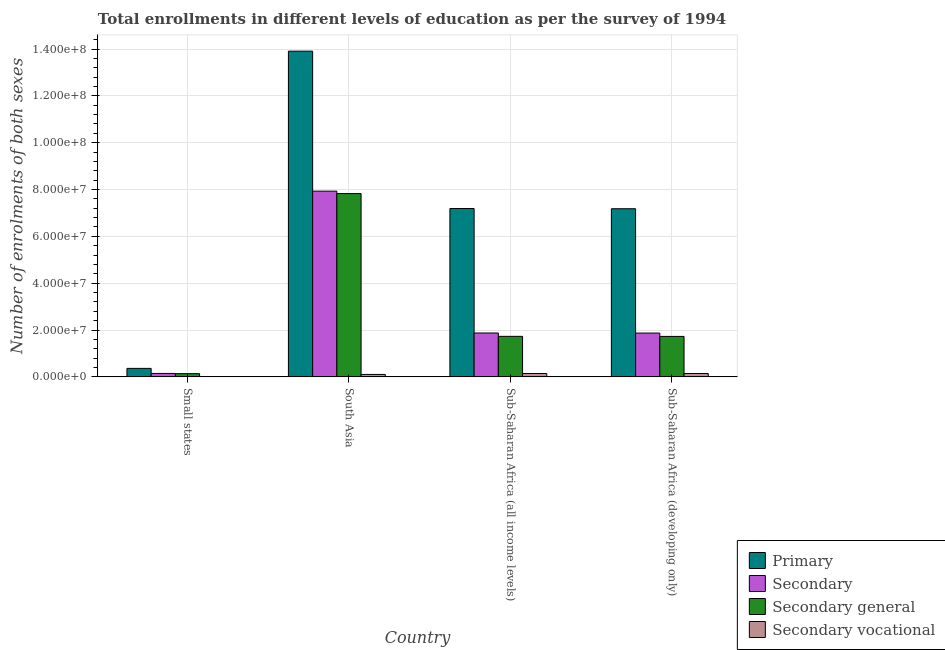How many bars are there on the 1st tick from the left?
Your response must be concise. 4. How many bars are there on the 2nd tick from the right?
Provide a short and direct response. 4. What is the label of the 1st group of bars from the left?
Keep it short and to the point. Small states. What is the number of enrolments in primary education in Sub-Saharan Africa (all income levels)?
Keep it short and to the point. 7.19e+07. Across all countries, what is the maximum number of enrolments in secondary education?
Your answer should be very brief. 7.93e+07. Across all countries, what is the minimum number of enrolments in secondary vocational education?
Your answer should be compact. 9.29e+04. In which country was the number of enrolments in primary education minimum?
Your answer should be compact. Small states. What is the total number of enrolments in secondary education in the graph?
Provide a short and direct response. 1.18e+08. What is the difference between the number of enrolments in secondary education in Sub-Saharan Africa (all income levels) and that in Sub-Saharan Africa (developing only)?
Make the answer very short. 2.59e+04. What is the difference between the number of enrolments in secondary general education in Small states and the number of enrolments in secondary vocational education in Sub-Saharan Africa (developing only)?
Give a very brief answer. -5.62e+04. What is the average number of enrolments in secondary education per country?
Keep it short and to the point. 2.96e+07. What is the difference between the number of enrolments in secondary education and number of enrolments in secondary vocational education in Small states?
Make the answer very short. 1.38e+06. What is the ratio of the number of enrolments in secondary education in Small states to that in South Asia?
Offer a very short reply. 0.02. Is the number of enrolments in primary education in Small states less than that in South Asia?
Your answer should be very brief. Yes. Is the difference between the number of enrolments in primary education in Small states and Sub-Saharan Africa (developing only) greater than the difference between the number of enrolments in secondary education in Small states and Sub-Saharan Africa (developing only)?
Give a very brief answer. No. What is the difference between the highest and the second highest number of enrolments in secondary general education?
Keep it short and to the point. 6.10e+07. What is the difference between the highest and the lowest number of enrolments in secondary education?
Ensure brevity in your answer.  7.78e+07. In how many countries, is the number of enrolments in primary education greater than the average number of enrolments in primary education taken over all countries?
Ensure brevity in your answer.  3. What does the 3rd bar from the left in Small states represents?
Your answer should be very brief. Secondary general. What does the 2nd bar from the right in South Asia represents?
Make the answer very short. Secondary general. How many bars are there?
Provide a short and direct response. 16. Are all the bars in the graph horizontal?
Provide a succinct answer. No. How many countries are there in the graph?
Your response must be concise. 4. What is the difference between two consecutive major ticks on the Y-axis?
Offer a terse response. 2.00e+07. Are the values on the major ticks of Y-axis written in scientific E-notation?
Keep it short and to the point. Yes. Where does the legend appear in the graph?
Your answer should be compact. Bottom right. What is the title of the graph?
Make the answer very short. Total enrollments in different levels of education as per the survey of 1994. Does "Manufacturing" appear as one of the legend labels in the graph?
Give a very brief answer. No. What is the label or title of the X-axis?
Offer a very short reply. Country. What is the label or title of the Y-axis?
Offer a terse response. Number of enrolments of both sexes. What is the Number of enrolments of both sexes in Primary in Small states?
Your response must be concise. 3.62e+06. What is the Number of enrolments of both sexes of Secondary in Small states?
Offer a terse response. 1.47e+06. What is the Number of enrolments of both sexes of Secondary general in Small states?
Provide a short and direct response. 1.38e+06. What is the Number of enrolments of both sexes in Secondary vocational in Small states?
Provide a succinct answer. 9.29e+04. What is the Number of enrolments of both sexes of Primary in South Asia?
Offer a very short reply. 1.39e+08. What is the Number of enrolments of both sexes in Secondary in South Asia?
Make the answer very short. 7.93e+07. What is the Number of enrolments of both sexes of Secondary general in South Asia?
Your answer should be very brief. 7.83e+07. What is the Number of enrolments of both sexes in Secondary vocational in South Asia?
Your response must be concise. 1.04e+06. What is the Number of enrolments of both sexes of Primary in Sub-Saharan Africa (all income levels)?
Offer a terse response. 7.19e+07. What is the Number of enrolments of both sexes in Secondary in Sub-Saharan Africa (all income levels)?
Offer a very short reply. 1.87e+07. What is the Number of enrolments of both sexes in Secondary general in Sub-Saharan Africa (all income levels)?
Make the answer very short. 1.73e+07. What is the Number of enrolments of both sexes of Secondary vocational in Sub-Saharan Africa (all income levels)?
Provide a short and direct response. 1.44e+06. What is the Number of enrolments of both sexes in Primary in Sub-Saharan Africa (developing only)?
Offer a terse response. 7.18e+07. What is the Number of enrolments of both sexes of Secondary in Sub-Saharan Africa (developing only)?
Offer a very short reply. 1.87e+07. What is the Number of enrolments of both sexes of Secondary general in Sub-Saharan Africa (developing only)?
Provide a short and direct response. 1.73e+07. What is the Number of enrolments of both sexes in Secondary vocational in Sub-Saharan Africa (developing only)?
Your answer should be compact. 1.44e+06. Across all countries, what is the maximum Number of enrolments of both sexes in Primary?
Offer a terse response. 1.39e+08. Across all countries, what is the maximum Number of enrolments of both sexes of Secondary?
Offer a very short reply. 7.93e+07. Across all countries, what is the maximum Number of enrolments of both sexes of Secondary general?
Your response must be concise. 7.83e+07. Across all countries, what is the maximum Number of enrolments of both sexes in Secondary vocational?
Offer a very short reply. 1.44e+06. Across all countries, what is the minimum Number of enrolments of both sexes in Primary?
Your answer should be compact. 3.62e+06. Across all countries, what is the minimum Number of enrolments of both sexes in Secondary?
Your response must be concise. 1.47e+06. Across all countries, what is the minimum Number of enrolments of both sexes in Secondary general?
Make the answer very short. 1.38e+06. Across all countries, what is the minimum Number of enrolments of both sexes of Secondary vocational?
Your answer should be compact. 9.29e+04. What is the total Number of enrolments of both sexes in Primary in the graph?
Make the answer very short. 2.86e+08. What is the total Number of enrolments of both sexes of Secondary in the graph?
Provide a short and direct response. 1.18e+08. What is the total Number of enrolments of both sexes of Secondary general in the graph?
Offer a very short reply. 1.14e+08. What is the total Number of enrolments of both sexes of Secondary vocational in the graph?
Your response must be concise. 4.01e+06. What is the difference between the Number of enrolments of both sexes of Primary in Small states and that in South Asia?
Your answer should be compact. -1.35e+08. What is the difference between the Number of enrolments of both sexes of Secondary in Small states and that in South Asia?
Make the answer very short. -7.78e+07. What is the difference between the Number of enrolments of both sexes in Secondary general in Small states and that in South Asia?
Your answer should be very brief. -7.69e+07. What is the difference between the Number of enrolments of both sexes in Secondary vocational in Small states and that in South Asia?
Offer a very short reply. -9.47e+05. What is the difference between the Number of enrolments of both sexes in Primary in Small states and that in Sub-Saharan Africa (all income levels)?
Ensure brevity in your answer.  -6.83e+07. What is the difference between the Number of enrolments of both sexes in Secondary in Small states and that in Sub-Saharan Africa (all income levels)?
Keep it short and to the point. -1.73e+07. What is the difference between the Number of enrolments of both sexes of Secondary general in Small states and that in Sub-Saharan Africa (all income levels)?
Make the answer very short. -1.59e+07. What is the difference between the Number of enrolments of both sexes in Secondary vocational in Small states and that in Sub-Saharan Africa (all income levels)?
Your answer should be very brief. -1.35e+06. What is the difference between the Number of enrolments of both sexes of Primary in Small states and that in Sub-Saharan Africa (developing only)?
Provide a succinct answer. -6.82e+07. What is the difference between the Number of enrolments of both sexes of Secondary in Small states and that in Sub-Saharan Africa (developing only)?
Provide a succinct answer. -1.72e+07. What is the difference between the Number of enrolments of both sexes of Secondary general in Small states and that in Sub-Saharan Africa (developing only)?
Provide a succinct answer. -1.59e+07. What is the difference between the Number of enrolments of both sexes in Secondary vocational in Small states and that in Sub-Saharan Africa (developing only)?
Your response must be concise. -1.34e+06. What is the difference between the Number of enrolments of both sexes in Primary in South Asia and that in Sub-Saharan Africa (all income levels)?
Offer a very short reply. 6.72e+07. What is the difference between the Number of enrolments of both sexes in Secondary in South Asia and that in Sub-Saharan Africa (all income levels)?
Keep it short and to the point. 6.06e+07. What is the difference between the Number of enrolments of both sexes in Secondary general in South Asia and that in Sub-Saharan Africa (all income levels)?
Provide a succinct answer. 6.10e+07. What is the difference between the Number of enrolments of both sexes in Secondary vocational in South Asia and that in Sub-Saharan Africa (all income levels)?
Your answer should be very brief. -3.99e+05. What is the difference between the Number of enrolments of both sexes in Primary in South Asia and that in Sub-Saharan Africa (developing only)?
Offer a terse response. 6.73e+07. What is the difference between the Number of enrolments of both sexes of Secondary in South Asia and that in Sub-Saharan Africa (developing only)?
Give a very brief answer. 6.06e+07. What is the difference between the Number of enrolments of both sexes in Secondary general in South Asia and that in Sub-Saharan Africa (developing only)?
Provide a short and direct response. 6.10e+07. What is the difference between the Number of enrolments of both sexes of Secondary vocational in South Asia and that in Sub-Saharan Africa (developing only)?
Your answer should be compact. -3.96e+05. What is the difference between the Number of enrolments of both sexes in Primary in Sub-Saharan Africa (all income levels) and that in Sub-Saharan Africa (developing only)?
Offer a very short reply. 8.57e+04. What is the difference between the Number of enrolments of both sexes in Secondary in Sub-Saharan Africa (all income levels) and that in Sub-Saharan Africa (developing only)?
Your answer should be very brief. 2.59e+04. What is the difference between the Number of enrolments of both sexes in Secondary general in Sub-Saharan Africa (all income levels) and that in Sub-Saharan Africa (developing only)?
Your response must be concise. 2.24e+04. What is the difference between the Number of enrolments of both sexes in Secondary vocational in Sub-Saharan Africa (all income levels) and that in Sub-Saharan Africa (developing only)?
Provide a short and direct response. 3508. What is the difference between the Number of enrolments of both sexes in Primary in Small states and the Number of enrolments of both sexes in Secondary in South Asia?
Ensure brevity in your answer.  -7.57e+07. What is the difference between the Number of enrolments of both sexes in Primary in Small states and the Number of enrolments of both sexes in Secondary general in South Asia?
Provide a short and direct response. -7.46e+07. What is the difference between the Number of enrolments of both sexes of Primary in Small states and the Number of enrolments of both sexes of Secondary vocational in South Asia?
Your answer should be compact. 2.58e+06. What is the difference between the Number of enrolments of both sexes of Secondary in Small states and the Number of enrolments of both sexes of Secondary general in South Asia?
Provide a succinct answer. -7.68e+07. What is the difference between the Number of enrolments of both sexes in Secondary in Small states and the Number of enrolments of both sexes in Secondary vocational in South Asia?
Give a very brief answer. 4.33e+05. What is the difference between the Number of enrolments of both sexes in Secondary general in Small states and the Number of enrolments of both sexes in Secondary vocational in South Asia?
Ensure brevity in your answer.  3.40e+05. What is the difference between the Number of enrolments of both sexes of Primary in Small states and the Number of enrolments of both sexes of Secondary in Sub-Saharan Africa (all income levels)?
Your answer should be very brief. -1.51e+07. What is the difference between the Number of enrolments of both sexes in Primary in Small states and the Number of enrolments of both sexes in Secondary general in Sub-Saharan Africa (all income levels)?
Keep it short and to the point. -1.37e+07. What is the difference between the Number of enrolments of both sexes in Primary in Small states and the Number of enrolments of both sexes in Secondary vocational in Sub-Saharan Africa (all income levels)?
Your answer should be very brief. 2.18e+06. What is the difference between the Number of enrolments of both sexes in Secondary in Small states and the Number of enrolments of both sexes in Secondary general in Sub-Saharan Africa (all income levels)?
Offer a very short reply. -1.58e+07. What is the difference between the Number of enrolments of both sexes in Secondary in Small states and the Number of enrolments of both sexes in Secondary vocational in Sub-Saharan Africa (all income levels)?
Your response must be concise. 3.33e+04. What is the difference between the Number of enrolments of both sexes in Secondary general in Small states and the Number of enrolments of both sexes in Secondary vocational in Sub-Saharan Africa (all income levels)?
Your response must be concise. -5.97e+04. What is the difference between the Number of enrolments of both sexes of Primary in Small states and the Number of enrolments of both sexes of Secondary in Sub-Saharan Africa (developing only)?
Ensure brevity in your answer.  -1.51e+07. What is the difference between the Number of enrolments of both sexes of Primary in Small states and the Number of enrolments of both sexes of Secondary general in Sub-Saharan Africa (developing only)?
Offer a very short reply. -1.37e+07. What is the difference between the Number of enrolments of both sexes of Primary in Small states and the Number of enrolments of both sexes of Secondary vocational in Sub-Saharan Africa (developing only)?
Provide a short and direct response. 2.19e+06. What is the difference between the Number of enrolments of both sexes in Secondary in Small states and the Number of enrolments of both sexes in Secondary general in Sub-Saharan Africa (developing only)?
Provide a succinct answer. -1.58e+07. What is the difference between the Number of enrolments of both sexes of Secondary in Small states and the Number of enrolments of both sexes of Secondary vocational in Sub-Saharan Africa (developing only)?
Offer a terse response. 3.68e+04. What is the difference between the Number of enrolments of both sexes in Secondary general in Small states and the Number of enrolments of both sexes in Secondary vocational in Sub-Saharan Africa (developing only)?
Keep it short and to the point. -5.62e+04. What is the difference between the Number of enrolments of both sexes of Primary in South Asia and the Number of enrolments of both sexes of Secondary in Sub-Saharan Africa (all income levels)?
Offer a very short reply. 1.20e+08. What is the difference between the Number of enrolments of both sexes of Primary in South Asia and the Number of enrolments of both sexes of Secondary general in Sub-Saharan Africa (all income levels)?
Provide a short and direct response. 1.22e+08. What is the difference between the Number of enrolments of both sexes of Primary in South Asia and the Number of enrolments of both sexes of Secondary vocational in Sub-Saharan Africa (all income levels)?
Keep it short and to the point. 1.38e+08. What is the difference between the Number of enrolments of both sexes of Secondary in South Asia and the Number of enrolments of both sexes of Secondary general in Sub-Saharan Africa (all income levels)?
Your answer should be very brief. 6.20e+07. What is the difference between the Number of enrolments of both sexes in Secondary in South Asia and the Number of enrolments of both sexes in Secondary vocational in Sub-Saharan Africa (all income levels)?
Provide a succinct answer. 7.79e+07. What is the difference between the Number of enrolments of both sexes of Secondary general in South Asia and the Number of enrolments of both sexes of Secondary vocational in Sub-Saharan Africa (all income levels)?
Keep it short and to the point. 7.68e+07. What is the difference between the Number of enrolments of both sexes of Primary in South Asia and the Number of enrolments of both sexes of Secondary in Sub-Saharan Africa (developing only)?
Your answer should be compact. 1.20e+08. What is the difference between the Number of enrolments of both sexes in Primary in South Asia and the Number of enrolments of both sexes in Secondary general in Sub-Saharan Africa (developing only)?
Offer a very short reply. 1.22e+08. What is the difference between the Number of enrolments of both sexes of Primary in South Asia and the Number of enrolments of both sexes of Secondary vocational in Sub-Saharan Africa (developing only)?
Ensure brevity in your answer.  1.38e+08. What is the difference between the Number of enrolments of both sexes in Secondary in South Asia and the Number of enrolments of both sexes in Secondary general in Sub-Saharan Africa (developing only)?
Provide a short and direct response. 6.20e+07. What is the difference between the Number of enrolments of both sexes in Secondary in South Asia and the Number of enrolments of both sexes in Secondary vocational in Sub-Saharan Africa (developing only)?
Make the answer very short. 7.79e+07. What is the difference between the Number of enrolments of both sexes in Secondary general in South Asia and the Number of enrolments of both sexes in Secondary vocational in Sub-Saharan Africa (developing only)?
Offer a very short reply. 7.68e+07. What is the difference between the Number of enrolments of both sexes of Primary in Sub-Saharan Africa (all income levels) and the Number of enrolments of both sexes of Secondary in Sub-Saharan Africa (developing only)?
Your answer should be compact. 5.32e+07. What is the difference between the Number of enrolments of both sexes of Primary in Sub-Saharan Africa (all income levels) and the Number of enrolments of both sexes of Secondary general in Sub-Saharan Africa (developing only)?
Give a very brief answer. 5.46e+07. What is the difference between the Number of enrolments of both sexes in Primary in Sub-Saharan Africa (all income levels) and the Number of enrolments of both sexes in Secondary vocational in Sub-Saharan Africa (developing only)?
Your response must be concise. 7.04e+07. What is the difference between the Number of enrolments of both sexes in Secondary in Sub-Saharan Africa (all income levels) and the Number of enrolments of both sexes in Secondary general in Sub-Saharan Africa (developing only)?
Your answer should be very brief. 1.46e+06. What is the difference between the Number of enrolments of both sexes of Secondary in Sub-Saharan Africa (all income levels) and the Number of enrolments of both sexes of Secondary vocational in Sub-Saharan Africa (developing only)?
Provide a short and direct response. 1.73e+07. What is the difference between the Number of enrolments of both sexes in Secondary general in Sub-Saharan Africa (all income levels) and the Number of enrolments of both sexes in Secondary vocational in Sub-Saharan Africa (developing only)?
Provide a succinct answer. 1.59e+07. What is the average Number of enrolments of both sexes in Primary per country?
Your answer should be very brief. 7.16e+07. What is the average Number of enrolments of both sexes of Secondary per country?
Your answer should be compact. 2.96e+07. What is the average Number of enrolments of both sexes in Secondary general per country?
Your answer should be very brief. 2.86e+07. What is the average Number of enrolments of both sexes of Secondary vocational per country?
Make the answer very short. 1.00e+06. What is the difference between the Number of enrolments of both sexes of Primary and Number of enrolments of both sexes of Secondary in Small states?
Your answer should be compact. 2.15e+06. What is the difference between the Number of enrolments of both sexes of Primary and Number of enrolments of both sexes of Secondary general in Small states?
Keep it short and to the point. 2.24e+06. What is the difference between the Number of enrolments of both sexes in Primary and Number of enrolments of both sexes in Secondary vocational in Small states?
Ensure brevity in your answer.  3.53e+06. What is the difference between the Number of enrolments of both sexes in Secondary and Number of enrolments of both sexes in Secondary general in Small states?
Provide a succinct answer. 9.29e+04. What is the difference between the Number of enrolments of both sexes in Secondary and Number of enrolments of both sexes in Secondary vocational in Small states?
Provide a short and direct response. 1.38e+06. What is the difference between the Number of enrolments of both sexes in Secondary general and Number of enrolments of both sexes in Secondary vocational in Small states?
Your answer should be compact. 1.29e+06. What is the difference between the Number of enrolments of both sexes of Primary and Number of enrolments of both sexes of Secondary in South Asia?
Provide a succinct answer. 5.98e+07. What is the difference between the Number of enrolments of both sexes in Primary and Number of enrolments of both sexes in Secondary general in South Asia?
Your response must be concise. 6.08e+07. What is the difference between the Number of enrolments of both sexes in Primary and Number of enrolments of both sexes in Secondary vocational in South Asia?
Offer a terse response. 1.38e+08. What is the difference between the Number of enrolments of both sexes of Secondary and Number of enrolments of both sexes of Secondary general in South Asia?
Provide a succinct answer. 1.04e+06. What is the difference between the Number of enrolments of both sexes of Secondary and Number of enrolments of both sexes of Secondary vocational in South Asia?
Ensure brevity in your answer.  7.83e+07. What is the difference between the Number of enrolments of both sexes in Secondary general and Number of enrolments of both sexes in Secondary vocational in South Asia?
Give a very brief answer. 7.72e+07. What is the difference between the Number of enrolments of both sexes of Primary and Number of enrolments of both sexes of Secondary in Sub-Saharan Africa (all income levels)?
Provide a succinct answer. 5.31e+07. What is the difference between the Number of enrolments of both sexes in Primary and Number of enrolments of both sexes in Secondary general in Sub-Saharan Africa (all income levels)?
Your answer should be very brief. 5.46e+07. What is the difference between the Number of enrolments of both sexes in Primary and Number of enrolments of both sexes in Secondary vocational in Sub-Saharan Africa (all income levels)?
Provide a short and direct response. 7.04e+07. What is the difference between the Number of enrolments of both sexes in Secondary and Number of enrolments of both sexes in Secondary general in Sub-Saharan Africa (all income levels)?
Keep it short and to the point. 1.44e+06. What is the difference between the Number of enrolments of both sexes in Secondary and Number of enrolments of both sexes in Secondary vocational in Sub-Saharan Africa (all income levels)?
Offer a very short reply. 1.73e+07. What is the difference between the Number of enrolments of both sexes of Secondary general and Number of enrolments of both sexes of Secondary vocational in Sub-Saharan Africa (all income levels)?
Make the answer very short. 1.59e+07. What is the difference between the Number of enrolments of both sexes of Primary and Number of enrolments of both sexes of Secondary in Sub-Saharan Africa (developing only)?
Offer a very short reply. 5.31e+07. What is the difference between the Number of enrolments of both sexes in Primary and Number of enrolments of both sexes in Secondary general in Sub-Saharan Africa (developing only)?
Your answer should be very brief. 5.45e+07. What is the difference between the Number of enrolments of both sexes in Primary and Number of enrolments of both sexes in Secondary vocational in Sub-Saharan Africa (developing only)?
Provide a short and direct response. 7.04e+07. What is the difference between the Number of enrolments of both sexes of Secondary and Number of enrolments of both sexes of Secondary general in Sub-Saharan Africa (developing only)?
Offer a very short reply. 1.44e+06. What is the difference between the Number of enrolments of both sexes of Secondary and Number of enrolments of both sexes of Secondary vocational in Sub-Saharan Africa (developing only)?
Your answer should be very brief. 1.73e+07. What is the difference between the Number of enrolments of both sexes in Secondary general and Number of enrolments of both sexes in Secondary vocational in Sub-Saharan Africa (developing only)?
Ensure brevity in your answer.  1.58e+07. What is the ratio of the Number of enrolments of both sexes of Primary in Small states to that in South Asia?
Your answer should be very brief. 0.03. What is the ratio of the Number of enrolments of both sexes of Secondary in Small states to that in South Asia?
Offer a terse response. 0.02. What is the ratio of the Number of enrolments of both sexes of Secondary general in Small states to that in South Asia?
Make the answer very short. 0.02. What is the ratio of the Number of enrolments of both sexes of Secondary vocational in Small states to that in South Asia?
Provide a short and direct response. 0.09. What is the ratio of the Number of enrolments of both sexes in Primary in Small states to that in Sub-Saharan Africa (all income levels)?
Make the answer very short. 0.05. What is the ratio of the Number of enrolments of both sexes of Secondary in Small states to that in Sub-Saharan Africa (all income levels)?
Your answer should be very brief. 0.08. What is the ratio of the Number of enrolments of both sexes in Secondary general in Small states to that in Sub-Saharan Africa (all income levels)?
Ensure brevity in your answer.  0.08. What is the ratio of the Number of enrolments of both sexes of Secondary vocational in Small states to that in Sub-Saharan Africa (all income levels)?
Provide a succinct answer. 0.06. What is the ratio of the Number of enrolments of both sexes in Primary in Small states to that in Sub-Saharan Africa (developing only)?
Your answer should be compact. 0.05. What is the ratio of the Number of enrolments of both sexes in Secondary in Small states to that in Sub-Saharan Africa (developing only)?
Provide a short and direct response. 0.08. What is the ratio of the Number of enrolments of both sexes in Secondary general in Small states to that in Sub-Saharan Africa (developing only)?
Ensure brevity in your answer.  0.08. What is the ratio of the Number of enrolments of both sexes in Secondary vocational in Small states to that in Sub-Saharan Africa (developing only)?
Your response must be concise. 0.06. What is the ratio of the Number of enrolments of both sexes in Primary in South Asia to that in Sub-Saharan Africa (all income levels)?
Your answer should be compact. 1.94. What is the ratio of the Number of enrolments of both sexes in Secondary in South Asia to that in Sub-Saharan Africa (all income levels)?
Provide a short and direct response. 4.23. What is the ratio of the Number of enrolments of both sexes of Secondary general in South Asia to that in Sub-Saharan Africa (all income levels)?
Offer a very short reply. 4.52. What is the ratio of the Number of enrolments of both sexes in Secondary vocational in South Asia to that in Sub-Saharan Africa (all income levels)?
Your answer should be compact. 0.72. What is the ratio of the Number of enrolments of both sexes in Primary in South Asia to that in Sub-Saharan Africa (developing only)?
Your answer should be very brief. 1.94. What is the ratio of the Number of enrolments of both sexes in Secondary in South Asia to that in Sub-Saharan Africa (developing only)?
Make the answer very short. 4.24. What is the ratio of the Number of enrolments of both sexes of Secondary general in South Asia to that in Sub-Saharan Africa (developing only)?
Your answer should be very brief. 4.53. What is the ratio of the Number of enrolments of both sexes of Secondary vocational in South Asia to that in Sub-Saharan Africa (developing only)?
Your response must be concise. 0.72. What is the difference between the highest and the second highest Number of enrolments of both sexes of Primary?
Keep it short and to the point. 6.72e+07. What is the difference between the highest and the second highest Number of enrolments of both sexes in Secondary?
Offer a very short reply. 6.06e+07. What is the difference between the highest and the second highest Number of enrolments of both sexes in Secondary general?
Provide a succinct answer. 6.10e+07. What is the difference between the highest and the second highest Number of enrolments of both sexes of Secondary vocational?
Your answer should be compact. 3508. What is the difference between the highest and the lowest Number of enrolments of both sexes of Primary?
Provide a short and direct response. 1.35e+08. What is the difference between the highest and the lowest Number of enrolments of both sexes in Secondary?
Your response must be concise. 7.78e+07. What is the difference between the highest and the lowest Number of enrolments of both sexes in Secondary general?
Give a very brief answer. 7.69e+07. What is the difference between the highest and the lowest Number of enrolments of both sexes in Secondary vocational?
Ensure brevity in your answer.  1.35e+06. 